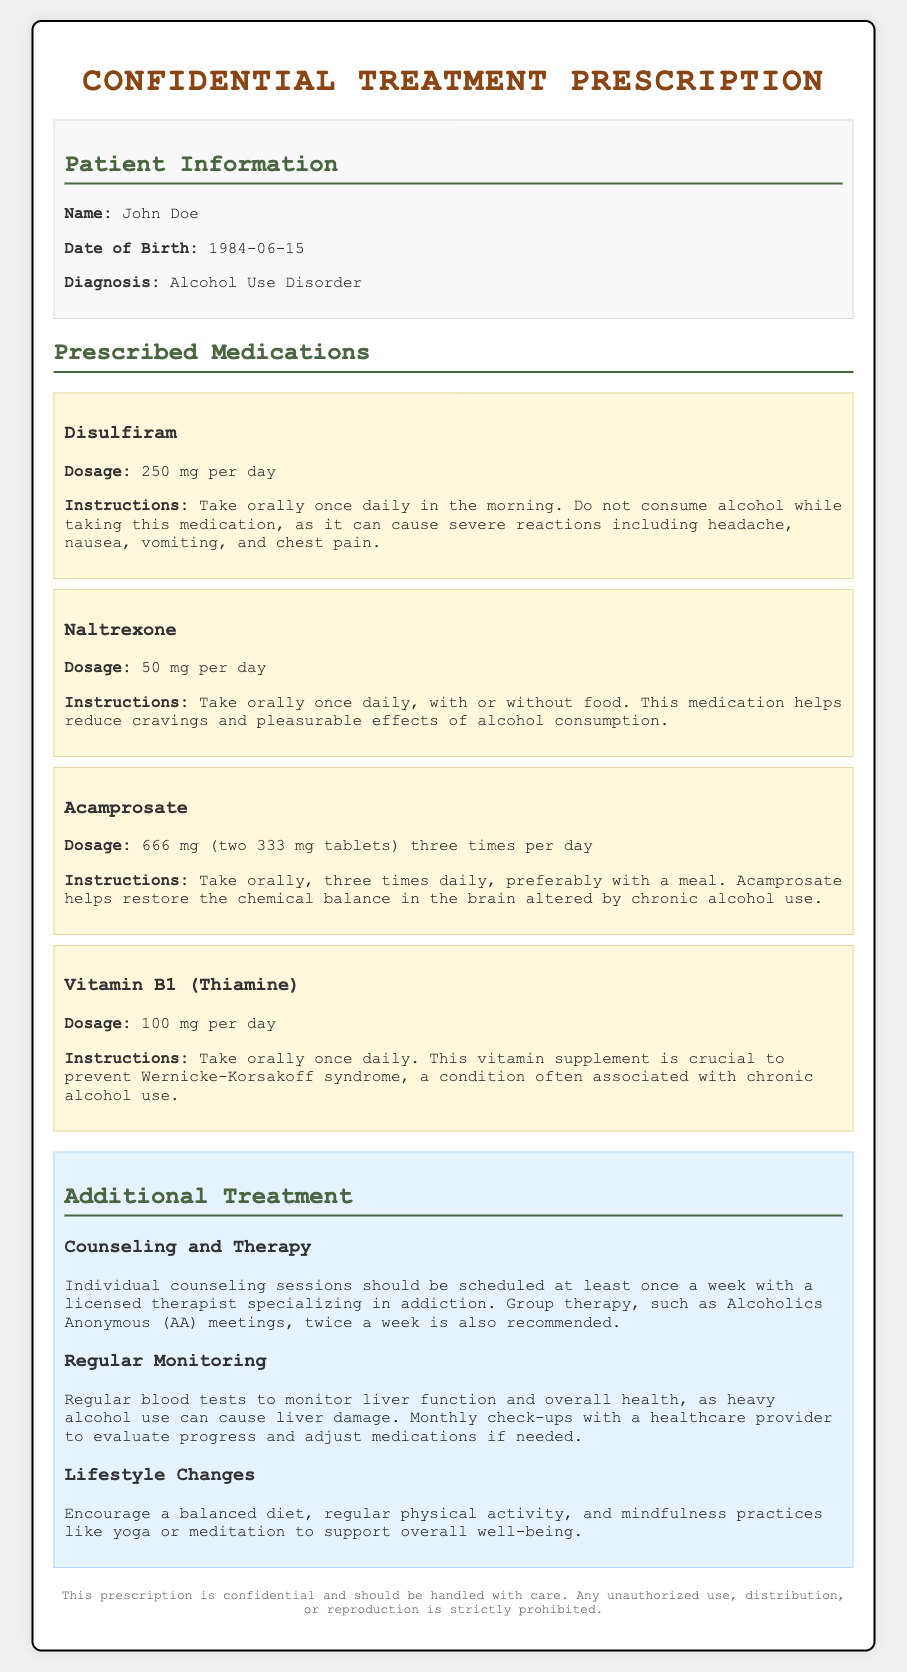What is the patient's name? The patient's name is listed in the patient information section of the document.
Answer: John Doe What is the diagnosis? The diagnosis is mentioned clearly in the patient information section of the document.
Answer: Alcohol Use Disorder What is the dosage of Disulfiram? The dosage for Disulfiram is included in the prescribed medications section.
Answer: 250 mg per day How often should Acamprosate be taken? The frequency of Administering Acamprosate is detailed under the medications section.
Answer: Three times per day What additional treatment is recommended alongside medication? The document specifies types of additional treatments recommended for the patient.
Answer: Counseling and Therapy What is the dosage for Vitamin B1? The prescribed dosage for Vitamin B1 can be found in the medications section.
Answer: 100 mg per day How many times a week should individual counseling sessions be scheduled? This detail is found in the additional treatment section regarding counseling.
Answer: Once a week What medication helps reduce cravings? The medication that aids in reducing cravings is described in the medications section.
Answer: Naltrexone What is the purpose of Vitamin B1? The intended effect of Vitamin B1 is explained in the instructions provided in the medications section.
Answer: Prevent Wernicke-Korsakoff syndrome 